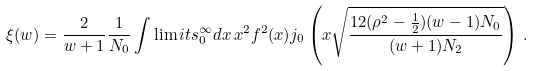Convert formula to latex. <formula><loc_0><loc_0><loc_500><loc_500>\xi ( w ) = \frac { 2 } { w + 1 } \frac { 1 } { N _ { 0 } } \int \lim i t s _ { 0 } ^ { \infty } d x \, x ^ { 2 } f ^ { 2 } ( x ) j _ { 0 } \left ( x \sqrt { \frac { 1 2 ( \rho ^ { 2 } - \frac { 1 } { 2 } ) ( w - 1 ) N _ { 0 } } { ( w + 1 ) N _ { 2 } } } \right ) \, .</formula> 